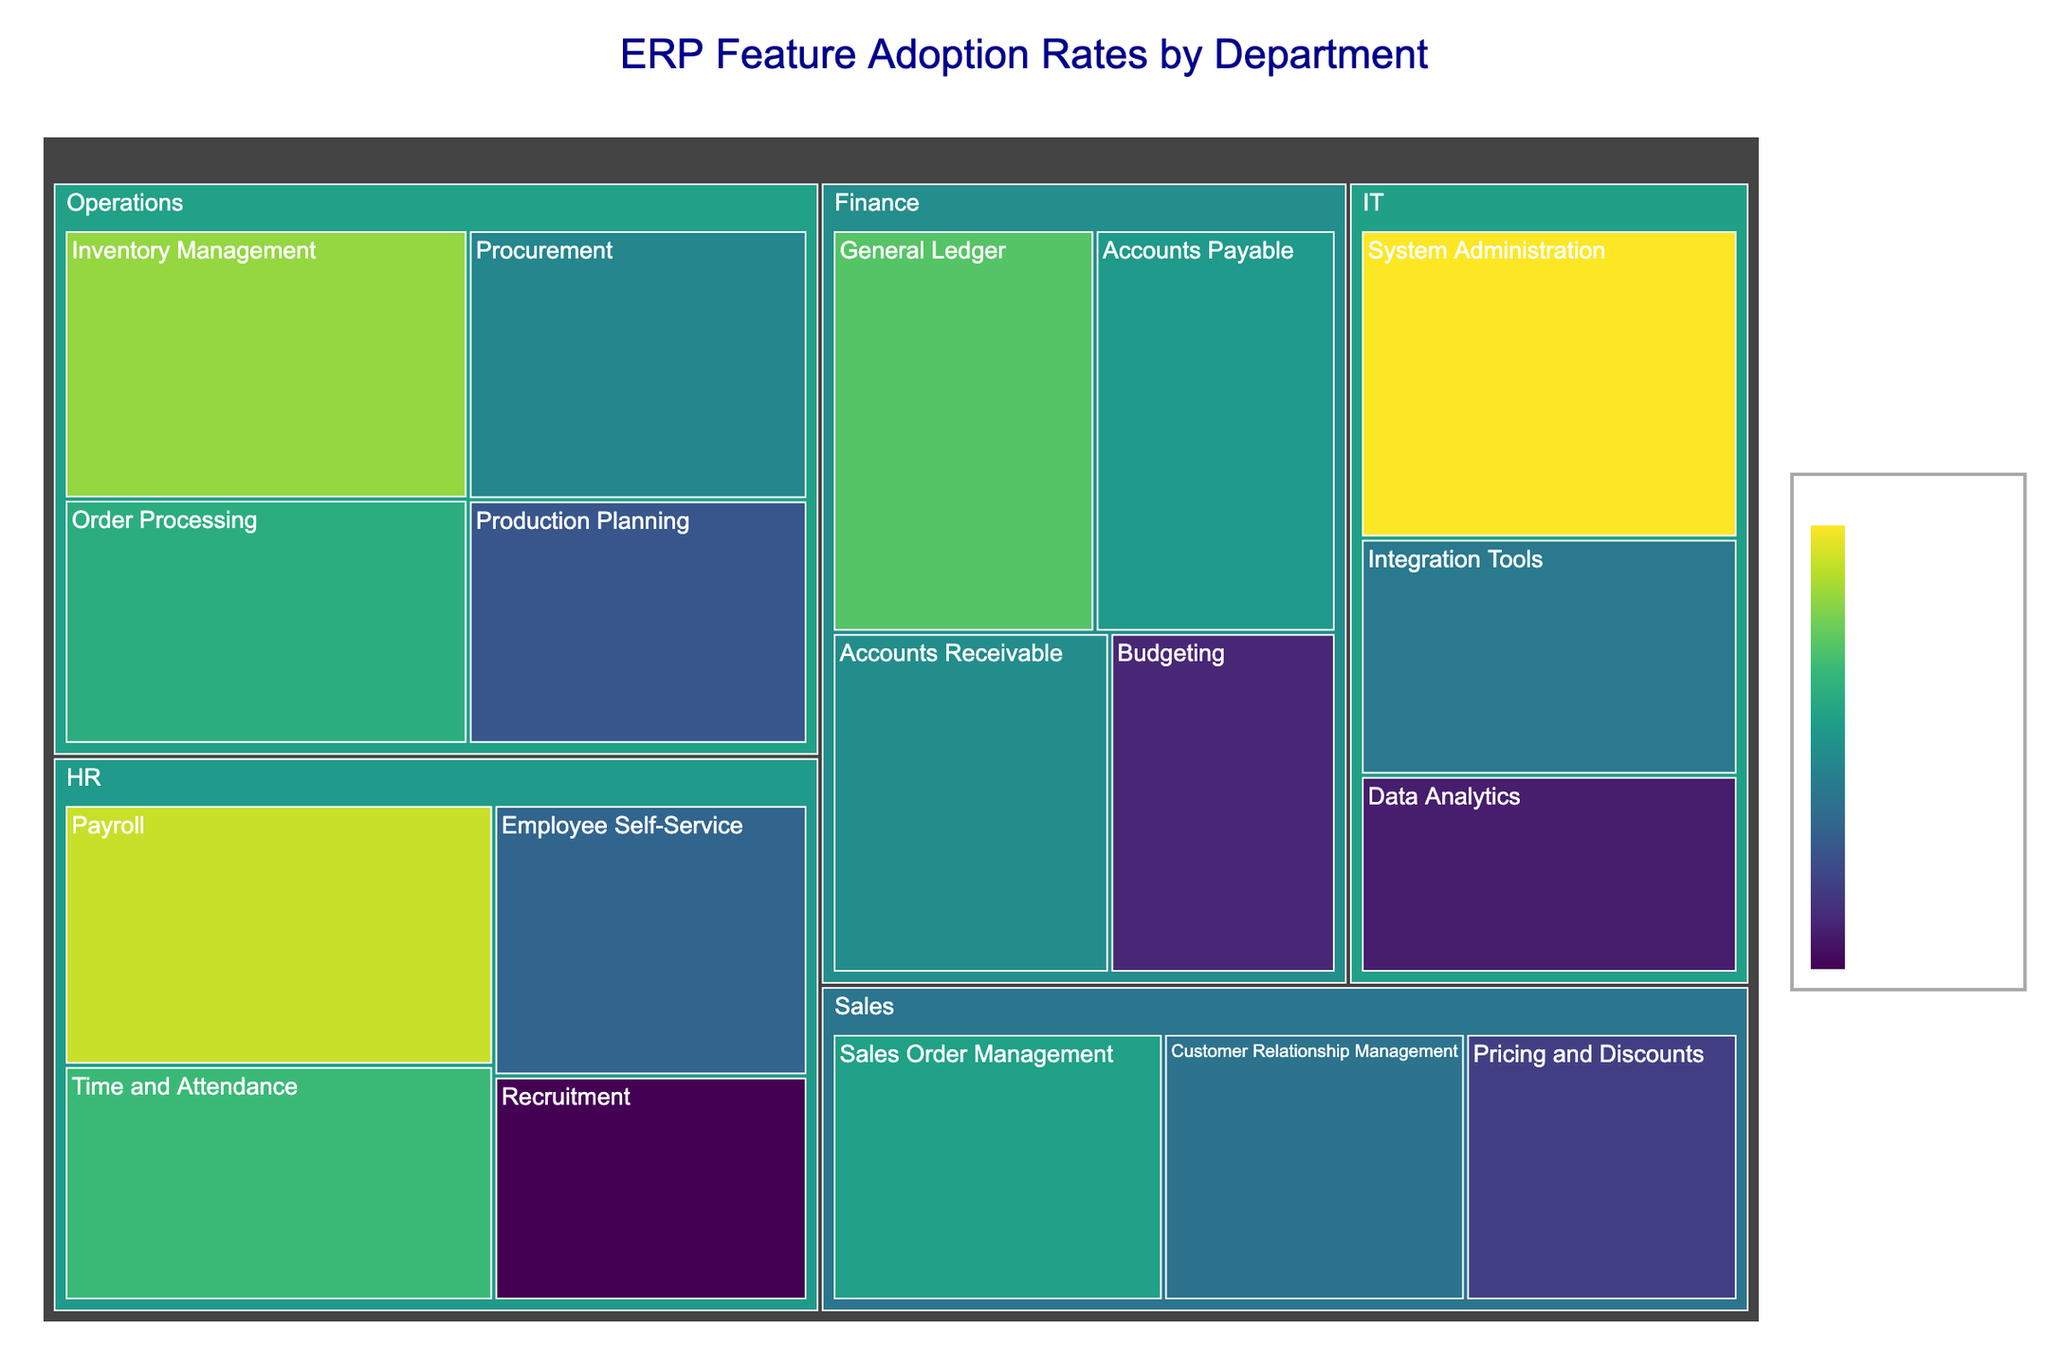What's the title of the treemap? The title is displayed at the top center of the treemap. It reads "ERP Feature Adoption Rates by Department".
Answer: ERP Feature Adoption Rates by Department Which ERP feature in the IT department has the highest adoption rate? Within the IT department rectangle, the sub-rectangle for "System Administration" is the largest and its color represents the highest adoption rate.
Answer: System Administration What is the average adoption rate of ERP features in the Finance department? To find the average, sum the adoption rates of all features in the Finance department and divide by the number of features. Calculation: (85 + 78 + 76 + 62) / 4 = 301 / 4 = 75.25.
Answer: 75.25% Which department has the lowest adopting feature, and what is its adoption rate? Hovering over the features or comparing their colors, we see that "Recruitment" in the HR department is both the smallest and the least intense in color.
Answer: HR, 58% Compare the adoption rates of "Inventory Management" in Operations and "Payroll" in HR. Which is higher? Hover over the feature areas until you find "Inventory Management" in Operations (89%) and "Payroll" in HR (92%). The latter is higher.
Answer: Payroll What is the adoption rate range across all features in the Sales department? Identify the minimum and maximum adoption rates in Sales by examining the sub-rectangles: min is 65% (Pricing and Discounts) and max is 79% (Sales Order Management).
Answer: 65% - 79% Which department shows the most variation in adoption rates among its features? Look for the department with the widest range between its highest and lowest adoption rates: Finance (85-62=23), HR (92-58=34), Operations (89-68=21), Sales (79-65=14), IT (95-61=34). Both HR and IT have the highest variation (34).
Answer: HR, IT What proportion of ERP features in the Finance department have an adoption rate above 75%? Count the features with adoption rates above 75%: General Ledger (85), Accounts Payable (78), Accounts Receivable (76). There are 3 out of 4 total features (3/4 = 0.75).
Answer: 75% How does the adoption rate for "Integration Tools" in IT compare to "Customer Relationship Management" in Sales? Hover over the features: "Integration Tools" is 73% and "Customer Relationship Management" is 72%. Compare their values to find that "Integration Tools" has a slightly higher adoption rate.
Answer: Integration Tools 